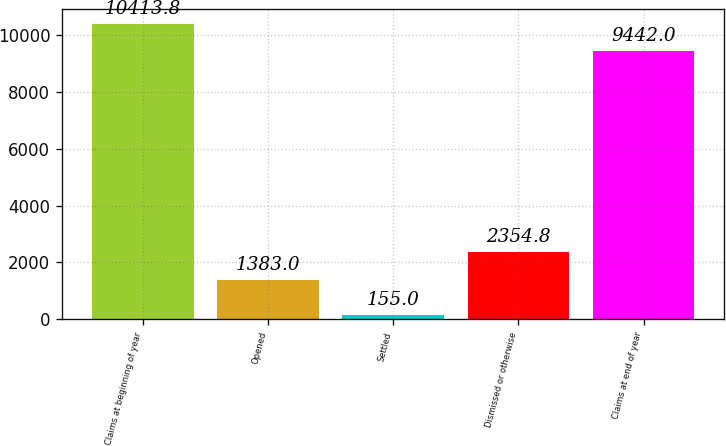Convert chart to OTSL. <chart><loc_0><loc_0><loc_500><loc_500><bar_chart><fcel>Claims at beginning of year<fcel>Opened<fcel>Settled<fcel>Dismissed or otherwise<fcel>Claims at end of year<nl><fcel>10413.8<fcel>1383<fcel>155<fcel>2354.8<fcel>9442<nl></chart> 